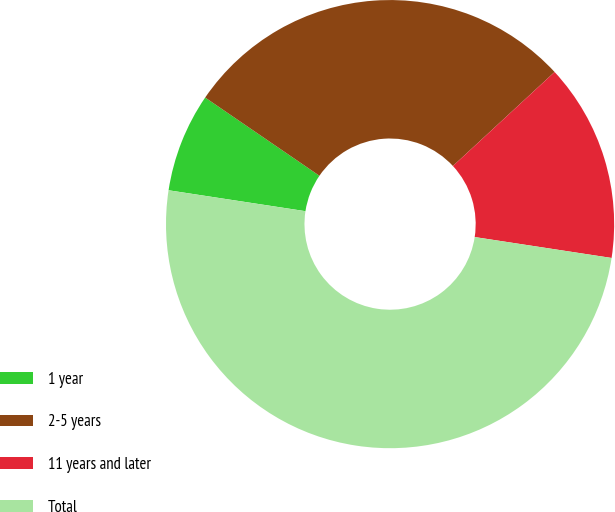<chart> <loc_0><loc_0><loc_500><loc_500><pie_chart><fcel>1 year<fcel>2-5 years<fcel>11 years and later<fcel>Total<nl><fcel>7.14%<fcel>28.57%<fcel>14.29%<fcel>50.0%<nl></chart> 